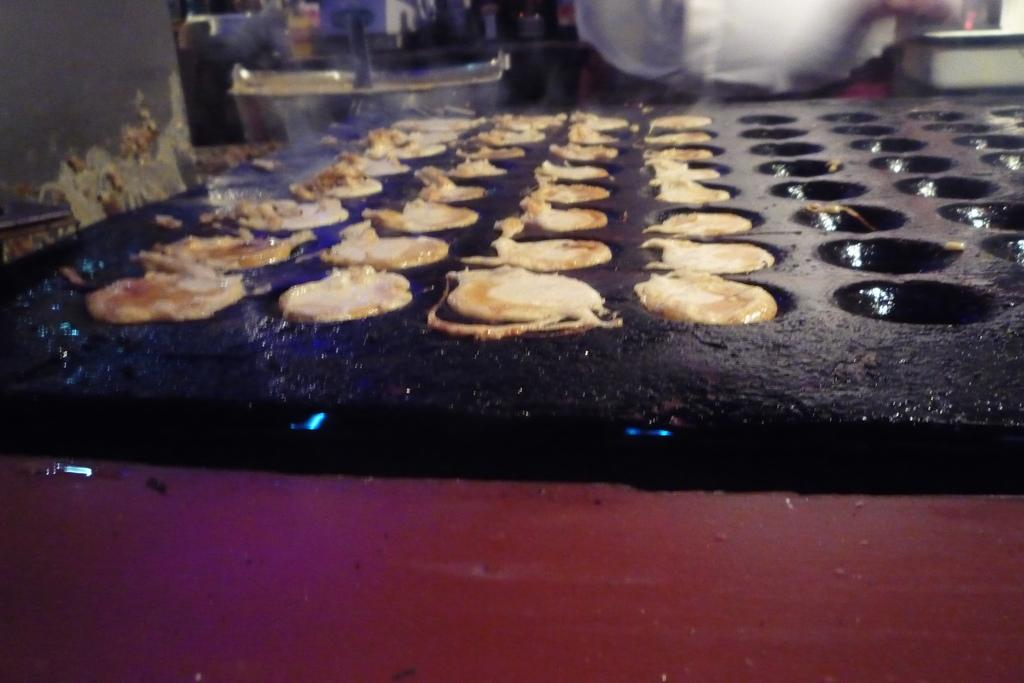What is the main object in the image? There is a food maker in the image. Can you describe the person in the image? A person is standing behind the food maker. What channel is the person watching on the television in the bedroom? There is no television or bedroom present in the image; it only features a food maker and a person standing behind it. 